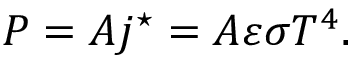<formula> <loc_0><loc_0><loc_500><loc_500>P = A j ^ { ^ { * } } = A \varepsilon \sigma T ^ { 4 } .</formula> 